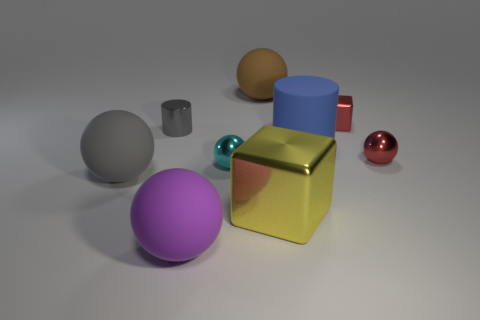How big is the metal cube in front of the small ball in front of the tiny shiny sphere that is right of the large brown ball?
Provide a short and direct response. Large. What size is the red thing that is the same material as the red ball?
Ensure brevity in your answer.  Small. What is the color of the thing that is in front of the brown ball and behind the gray cylinder?
Offer a very short reply. Red. Does the rubber object right of the brown object have the same shape as the large object in front of the big yellow metallic cube?
Ensure brevity in your answer.  No. There is a cylinder that is to the left of the purple ball; what is it made of?
Offer a very short reply. Metal. What size is the thing that is the same color as the small block?
Keep it short and to the point. Small. What number of things are big matte objects behind the big purple rubber sphere or small purple matte cubes?
Keep it short and to the point. 3. Is the number of tiny gray metallic objects to the right of the large cylinder the same as the number of big brown metallic blocks?
Offer a very short reply. Yes. Does the blue rubber thing have the same size as the yellow shiny thing?
Keep it short and to the point. Yes. What color is the cylinder that is the same size as the purple matte thing?
Your answer should be compact. Blue. 